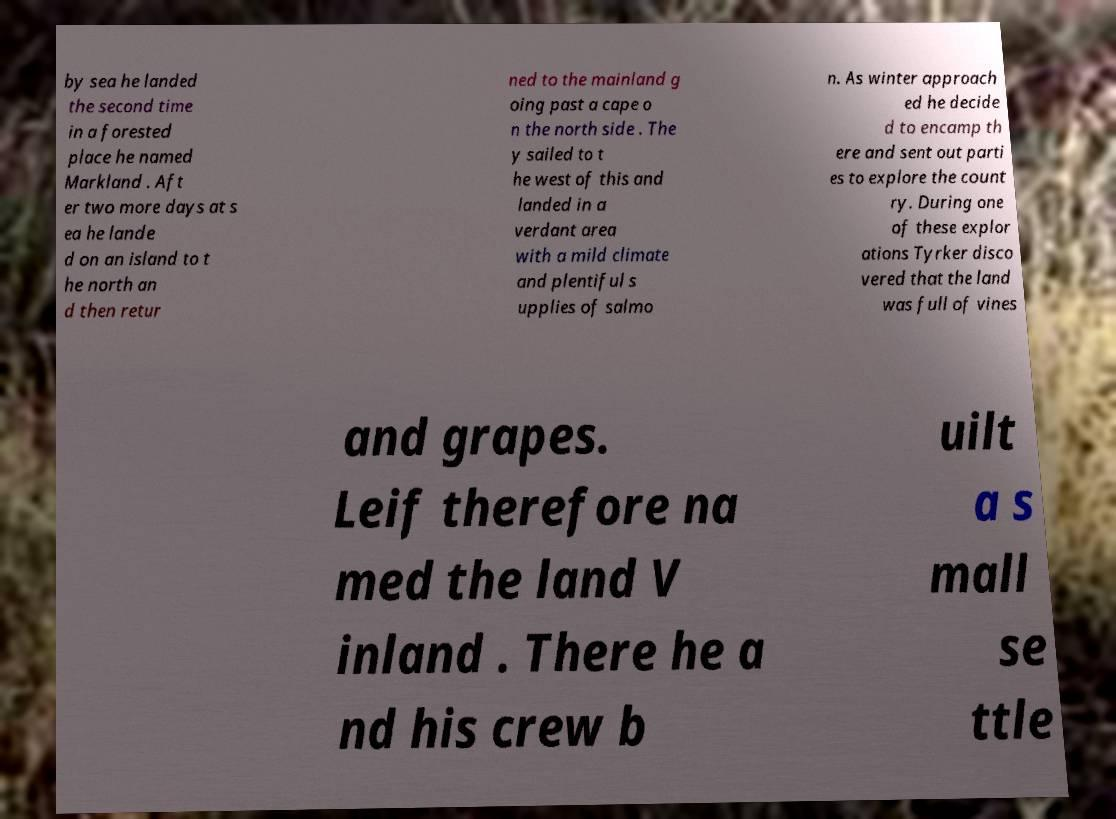For documentation purposes, I need the text within this image transcribed. Could you provide that? by sea he landed the second time in a forested place he named Markland . Aft er two more days at s ea he lande d on an island to t he north an d then retur ned to the mainland g oing past a cape o n the north side . The y sailed to t he west of this and landed in a verdant area with a mild climate and plentiful s upplies of salmo n. As winter approach ed he decide d to encamp th ere and sent out parti es to explore the count ry. During one of these explor ations Tyrker disco vered that the land was full of vines and grapes. Leif therefore na med the land V inland . There he a nd his crew b uilt a s mall se ttle 